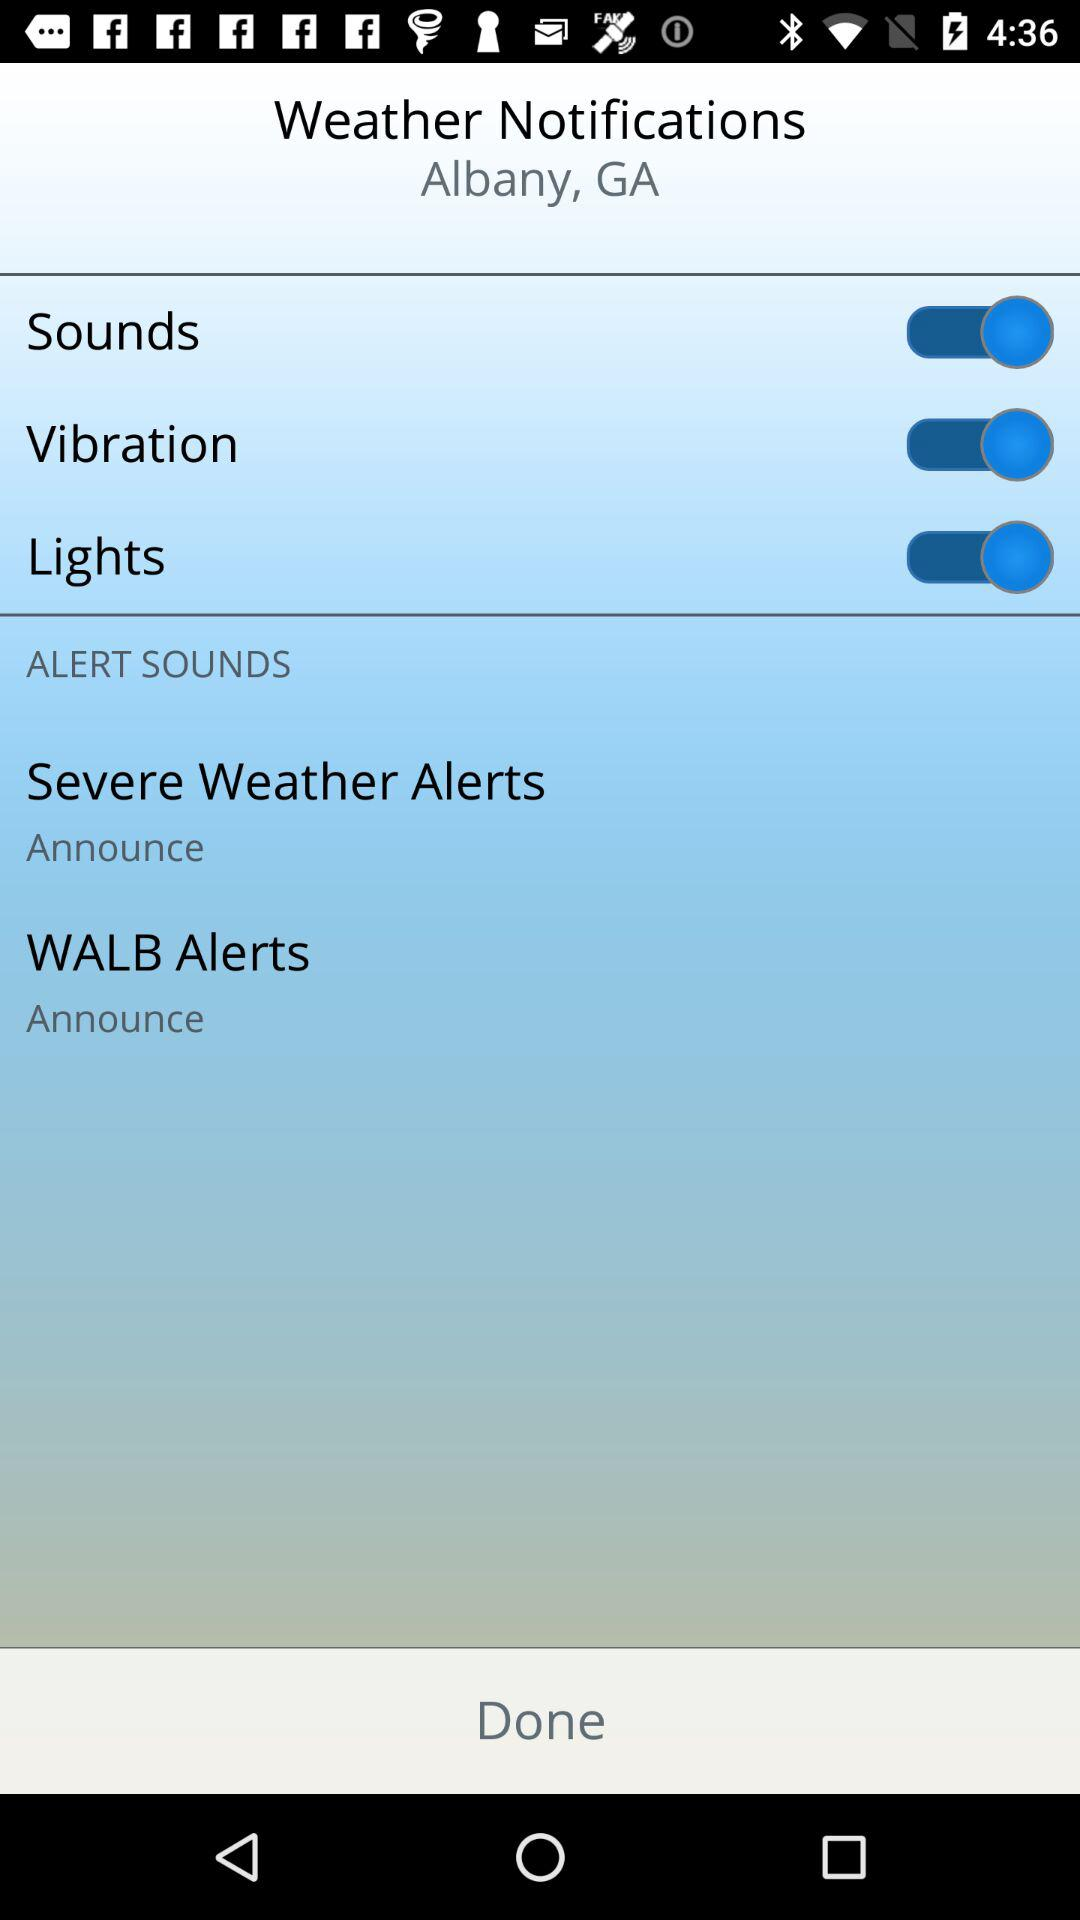What is the location? The location is Albany, GA. 